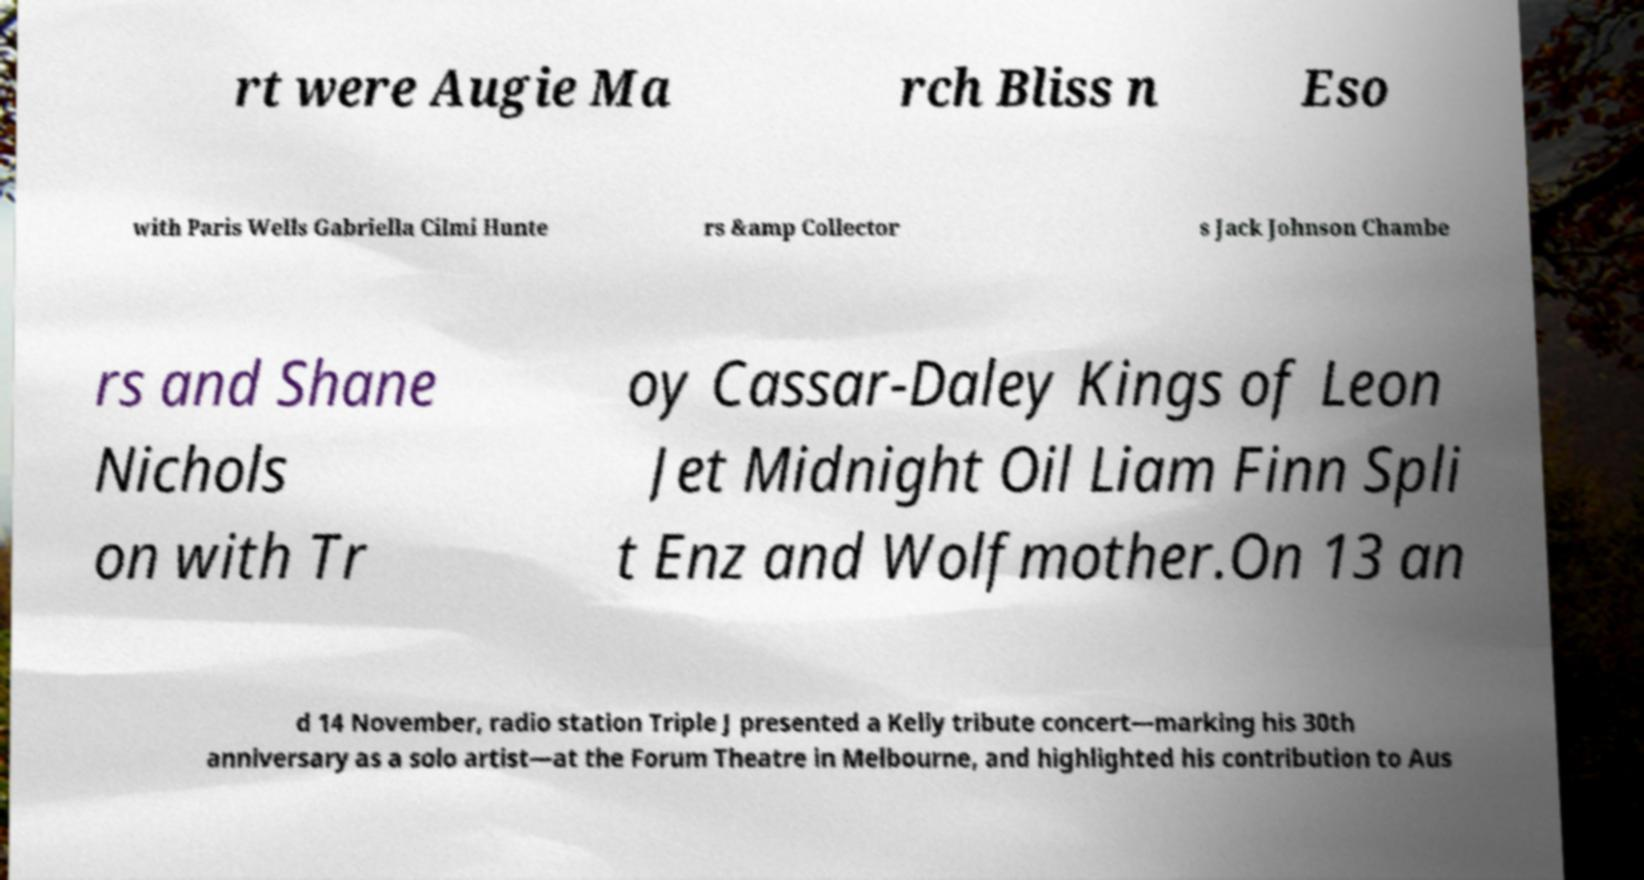Please identify and transcribe the text found in this image. rt were Augie Ma rch Bliss n Eso with Paris Wells Gabriella Cilmi Hunte rs &amp Collector s Jack Johnson Chambe rs and Shane Nichols on with Tr oy Cassar-Daley Kings of Leon Jet Midnight Oil Liam Finn Spli t Enz and Wolfmother.On 13 an d 14 November, radio station Triple J presented a Kelly tribute concert—marking his 30th anniversary as a solo artist—at the Forum Theatre in Melbourne, and highlighted his contribution to Aus 